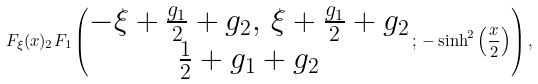Convert formula to latex. <formula><loc_0><loc_0><loc_500><loc_500>F _ { \xi } ( x ) _ { 2 } F _ { 1 } \left ( \begin{matrix} - \xi + \frac { g _ { 1 } } { 2 } + g _ { 2 } , \, \xi + \frac { g _ { 1 } } { 2 } + g _ { 2 } \\ \frac { 1 } { 2 } + g _ { 1 } + g _ { 2 } \end{matrix} \, ; \, - \sinh ^ { 2 } \left ( \frac { x } { 2 } \right ) \right ) ,</formula> 